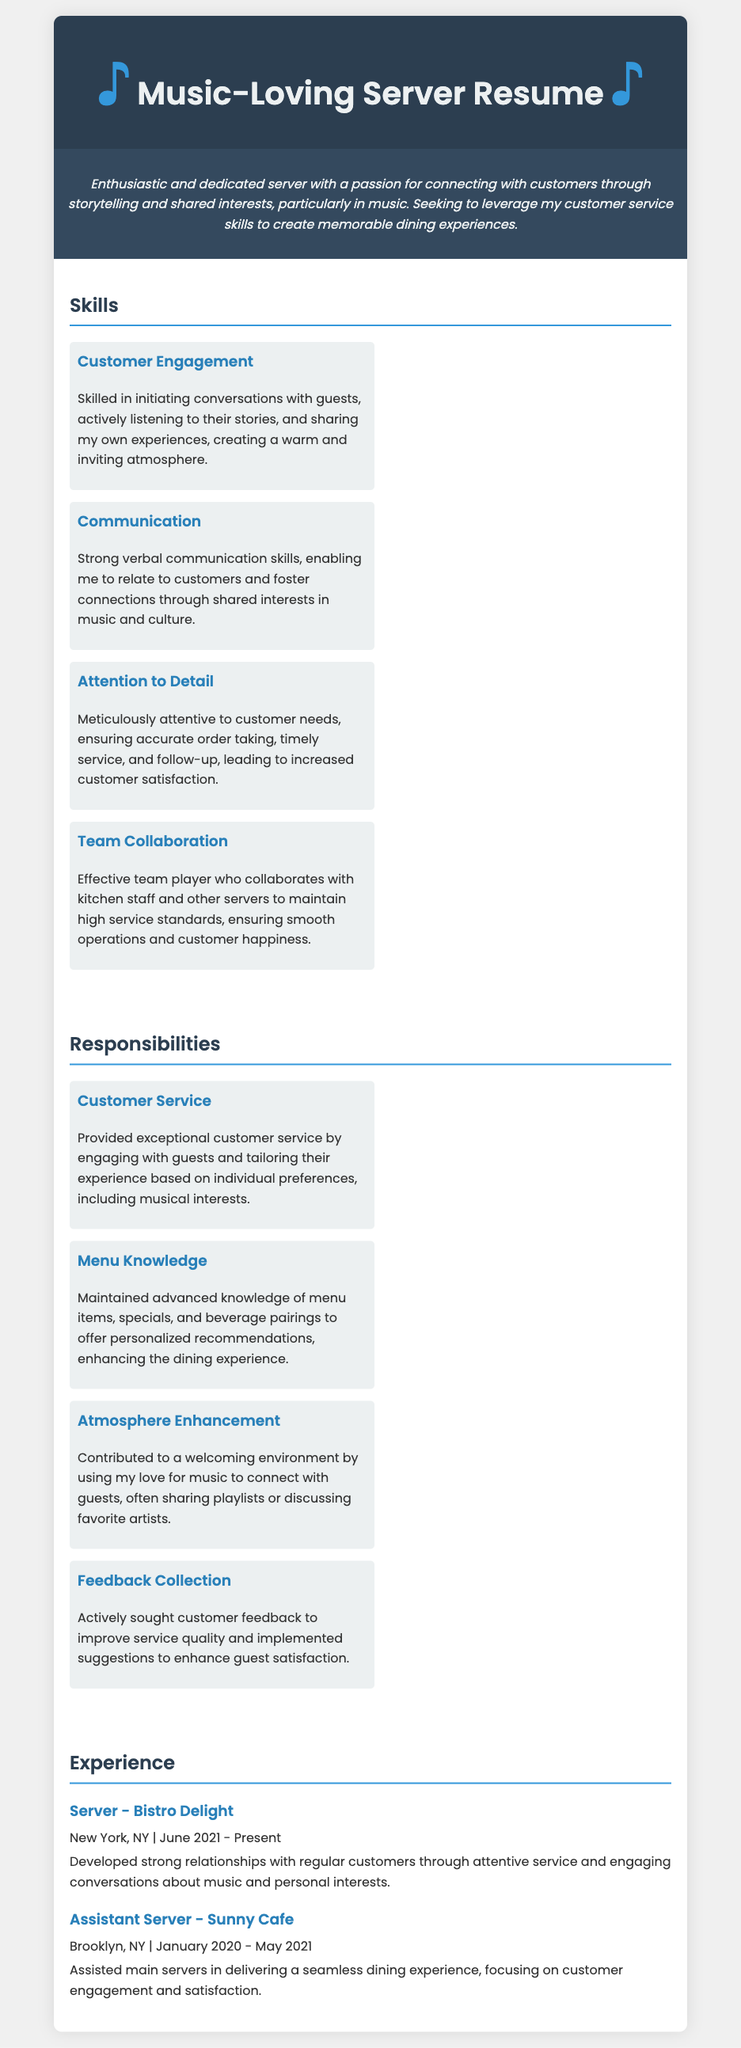What is the name of the restaurant where the server currently works? The server currently works at "Bistro Delight," as mentioned in the experience section.
Answer: Bistro Delight What city is Bistro Delight located in? The experience section lists "New York, NY" as the location for Bistro Delight.
Answer: New York, NY In what year did the server start working at Sunny Cafe? The resume indicates that the server began working at Sunny Cafe in January 2020.
Answer: January 2020 What is one skill mentioned that showcases the server's ability to connect with customers? The skills section lists "Customer Engagement," which highlights the server's ability to connect through storytelling.
Answer: Customer Engagement What is the main objective of the server as stated in the resume? The objective section expresses a desire to connect with customers and enhance their dining experience.
Answer: Connect with customers How long has the server been at Bistro Delight? The experience at Bistro Delight started in June 2021 and the current time is assumed to be in 2023, giving a duration of about 2 years.
Answer: About 2 years What type of atmosphere does the server contribute to according to the responsibilities? The responsibilities state that the server contributes to a "welcoming environment."
Answer: Welcoming environment What is one method the server uses to relate to guests? The skills section mentions relating through shared interests, particularly in music and culture.
Answer: Shared interests in music What role did the server hold at Sunny Cafe? The experience section identifies the server's position at Sunny Cafe as "Assistant Server."
Answer: Assistant Server 